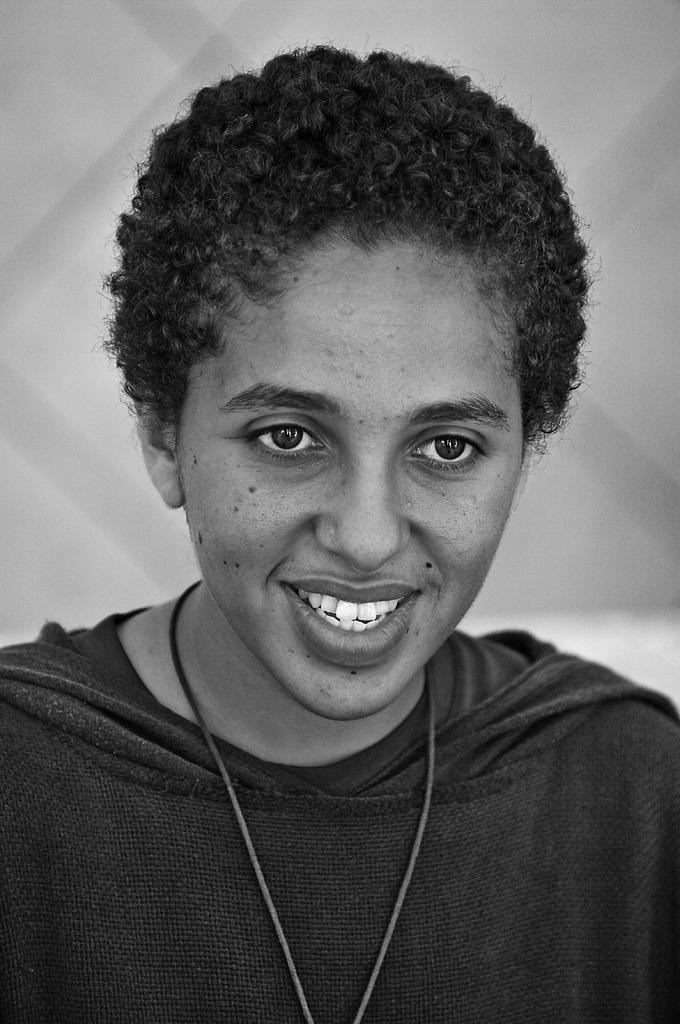Could you give a brief overview of what you see in this image? This is the picture of a black and white image and we can see a person with a smiley face and there is a white background. 